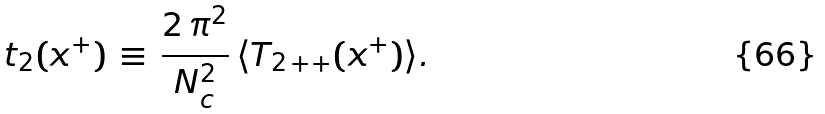Convert formula to latex. <formula><loc_0><loc_0><loc_500><loc_500>t _ { 2 } ( x ^ { + } ) \, \equiv \, \frac { 2 \, \pi ^ { 2 } } { N _ { c } ^ { 2 } } \, \langle T _ { 2 \, + + } ( x ^ { + } ) \rangle .</formula> 